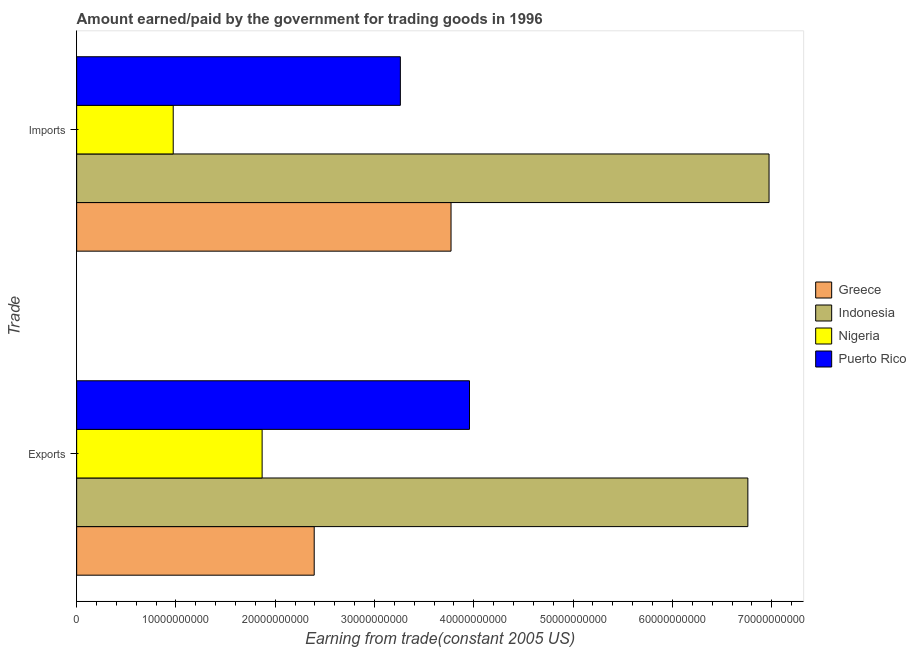Are the number of bars on each tick of the Y-axis equal?
Make the answer very short. Yes. How many bars are there on the 1st tick from the bottom?
Offer a terse response. 4. What is the label of the 1st group of bars from the top?
Your answer should be very brief. Imports. What is the amount paid for imports in Nigeria?
Your response must be concise. 9.72e+09. Across all countries, what is the maximum amount paid for imports?
Offer a very short reply. 6.97e+1. Across all countries, what is the minimum amount earned from exports?
Provide a succinct answer. 1.87e+1. In which country was the amount earned from exports minimum?
Give a very brief answer. Nigeria. What is the total amount paid for imports in the graph?
Offer a very short reply. 1.50e+11. What is the difference between the amount paid for imports in Nigeria and that in Greece?
Keep it short and to the point. -2.80e+1. What is the difference between the amount paid for imports in Puerto Rico and the amount earned from exports in Indonesia?
Give a very brief answer. -3.50e+1. What is the average amount earned from exports per country?
Your answer should be compact. 3.74e+1. What is the difference between the amount earned from exports and amount paid for imports in Nigeria?
Make the answer very short. 8.95e+09. In how many countries, is the amount paid for imports greater than 10000000000 US$?
Your response must be concise. 3. What is the ratio of the amount earned from exports in Greece to that in Nigeria?
Your answer should be very brief. 1.28. Is the amount paid for imports in Puerto Rico less than that in Indonesia?
Ensure brevity in your answer.  Yes. What does the 3rd bar from the top in Exports represents?
Make the answer very short. Indonesia. What does the 2nd bar from the bottom in Imports represents?
Keep it short and to the point. Indonesia. How many bars are there?
Give a very brief answer. 8. Are all the bars in the graph horizontal?
Your response must be concise. Yes. How many countries are there in the graph?
Provide a short and direct response. 4. What is the difference between two consecutive major ticks on the X-axis?
Give a very brief answer. 1.00e+1. Where does the legend appear in the graph?
Ensure brevity in your answer.  Center right. How are the legend labels stacked?
Your answer should be compact. Vertical. What is the title of the graph?
Provide a short and direct response. Amount earned/paid by the government for trading goods in 1996. Does "Virgin Islands" appear as one of the legend labels in the graph?
Make the answer very short. No. What is the label or title of the X-axis?
Provide a succinct answer. Earning from trade(constant 2005 US). What is the label or title of the Y-axis?
Provide a short and direct response. Trade. What is the Earning from trade(constant 2005 US) in Greece in Exports?
Your answer should be very brief. 2.39e+1. What is the Earning from trade(constant 2005 US) in Indonesia in Exports?
Provide a short and direct response. 6.76e+1. What is the Earning from trade(constant 2005 US) of Nigeria in Exports?
Keep it short and to the point. 1.87e+1. What is the Earning from trade(constant 2005 US) in Puerto Rico in Exports?
Offer a terse response. 3.96e+1. What is the Earning from trade(constant 2005 US) in Greece in Imports?
Your answer should be compact. 3.77e+1. What is the Earning from trade(constant 2005 US) of Indonesia in Imports?
Provide a short and direct response. 6.97e+1. What is the Earning from trade(constant 2005 US) in Nigeria in Imports?
Make the answer very short. 9.72e+09. What is the Earning from trade(constant 2005 US) in Puerto Rico in Imports?
Make the answer very short. 3.26e+1. Across all Trade, what is the maximum Earning from trade(constant 2005 US) in Greece?
Give a very brief answer. 3.77e+1. Across all Trade, what is the maximum Earning from trade(constant 2005 US) of Indonesia?
Make the answer very short. 6.97e+1. Across all Trade, what is the maximum Earning from trade(constant 2005 US) in Nigeria?
Provide a short and direct response. 1.87e+1. Across all Trade, what is the maximum Earning from trade(constant 2005 US) in Puerto Rico?
Provide a succinct answer. 3.96e+1. Across all Trade, what is the minimum Earning from trade(constant 2005 US) in Greece?
Offer a terse response. 2.39e+1. Across all Trade, what is the minimum Earning from trade(constant 2005 US) of Indonesia?
Offer a very short reply. 6.76e+1. Across all Trade, what is the minimum Earning from trade(constant 2005 US) in Nigeria?
Your response must be concise. 9.72e+09. Across all Trade, what is the minimum Earning from trade(constant 2005 US) of Puerto Rico?
Offer a terse response. 3.26e+1. What is the total Earning from trade(constant 2005 US) in Greece in the graph?
Ensure brevity in your answer.  6.16e+1. What is the total Earning from trade(constant 2005 US) in Indonesia in the graph?
Your answer should be compact. 1.37e+11. What is the total Earning from trade(constant 2005 US) of Nigeria in the graph?
Provide a short and direct response. 2.84e+1. What is the total Earning from trade(constant 2005 US) in Puerto Rico in the graph?
Provide a short and direct response. 7.22e+1. What is the difference between the Earning from trade(constant 2005 US) in Greece in Exports and that in Imports?
Provide a short and direct response. -1.38e+1. What is the difference between the Earning from trade(constant 2005 US) in Indonesia in Exports and that in Imports?
Provide a short and direct response. -2.13e+09. What is the difference between the Earning from trade(constant 2005 US) of Nigeria in Exports and that in Imports?
Give a very brief answer. 8.95e+09. What is the difference between the Earning from trade(constant 2005 US) of Puerto Rico in Exports and that in Imports?
Provide a short and direct response. 6.96e+09. What is the difference between the Earning from trade(constant 2005 US) of Greece in Exports and the Earning from trade(constant 2005 US) of Indonesia in Imports?
Your answer should be very brief. -4.58e+1. What is the difference between the Earning from trade(constant 2005 US) in Greece in Exports and the Earning from trade(constant 2005 US) in Nigeria in Imports?
Provide a short and direct response. 1.42e+1. What is the difference between the Earning from trade(constant 2005 US) in Greece in Exports and the Earning from trade(constant 2005 US) in Puerto Rico in Imports?
Your answer should be very brief. -8.68e+09. What is the difference between the Earning from trade(constant 2005 US) in Indonesia in Exports and the Earning from trade(constant 2005 US) in Nigeria in Imports?
Provide a short and direct response. 5.79e+1. What is the difference between the Earning from trade(constant 2005 US) of Indonesia in Exports and the Earning from trade(constant 2005 US) of Puerto Rico in Imports?
Ensure brevity in your answer.  3.50e+1. What is the difference between the Earning from trade(constant 2005 US) of Nigeria in Exports and the Earning from trade(constant 2005 US) of Puerto Rico in Imports?
Provide a short and direct response. -1.39e+1. What is the average Earning from trade(constant 2005 US) in Greece per Trade?
Make the answer very short. 3.08e+1. What is the average Earning from trade(constant 2005 US) in Indonesia per Trade?
Give a very brief answer. 6.87e+1. What is the average Earning from trade(constant 2005 US) of Nigeria per Trade?
Your answer should be very brief. 1.42e+1. What is the average Earning from trade(constant 2005 US) of Puerto Rico per Trade?
Give a very brief answer. 3.61e+1. What is the difference between the Earning from trade(constant 2005 US) in Greece and Earning from trade(constant 2005 US) in Indonesia in Exports?
Provide a short and direct response. -4.37e+1. What is the difference between the Earning from trade(constant 2005 US) of Greece and Earning from trade(constant 2005 US) of Nigeria in Exports?
Provide a short and direct response. 5.24e+09. What is the difference between the Earning from trade(constant 2005 US) in Greece and Earning from trade(constant 2005 US) in Puerto Rico in Exports?
Provide a short and direct response. -1.56e+1. What is the difference between the Earning from trade(constant 2005 US) in Indonesia and Earning from trade(constant 2005 US) in Nigeria in Exports?
Offer a terse response. 4.89e+1. What is the difference between the Earning from trade(constant 2005 US) of Indonesia and Earning from trade(constant 2005 US) of Puerto Rico in Exports?
Your answer should be compact. 2.80e+1. What is the difference between the Earning from trade(constant 2005 US) in Nigeria and Earning from trade(constant 2005 US) in Puerto Rico in Exports?
Provide a succinct answer. -2.09e+1. What is the difference between the Earning from trade(constant 2005 US) of Greece and Earning from trade(constant 2005 US) of Indonesia in Imports?
Offer a terse response. -3.20e+1. What is the difference between the Earning from trade(constant 2005 US) in Greece and Earning from trade(constant 2005 US) in Nigeria in Imports?
Ensure brevity in your answer.  2.80e+1. What is the difference between the Earning from trade(constant 2005 US) in Greece and Earning from trade(constant 2005 US) in Puerto Rico in Imports?
Offer a very short reply. 5.10e+09. What is the difference between the Earning from trade(constant 2005 US) in Indonesia and Earning from trade(constant 2005 US) in Nigeria in Imports?
Make the answer very short. 6.00e+1. What is the difference between the Earning from trade(constant 2005 US) in Indonesia and Earning from trade(constant 2005 US) in Puerto Rico in Imports?
Your response must be concise. 3.71e+1. What is the difference between the Earning from trade(constant 2005 US) in Nigeria and Earning from trade(constant 2005 US) in Puerto Rico in Imports?
Offer a very short reply. -2.29e+1. What is the ratio of the Earning from trade(constant 2005 US) in Greece in Exports to that in Imports?
Offer a very short reply. 0.63. What is the ratio of the Earning from trade(constant 2005 US) of Indonesia in Exports to that in Imports?
Offer a terse response. 0.97. What is the ratio of the Earning from trade(constant 2005 US) in Nigeria in Exports to that in Imports?
Offer a terse response. 1.92. What is the ratio of the Earning from trade(constant 2005 US) of Puerto Rico in Exports to that in Imports?
Provide a short and direct response. 1.21. What is the difference between the highest and the second highest Earning from trade(constant 2005 US) of Greece?
Your answer should be compact. 1.38e+1. What is the difference between the highest and the second highest Earning from trade(constant 2005 US) of Indonesia?
Offer a very short reply. 2.13e+09. What is the difference between the highest and the second highest Earning from trade(constant 2005 US) of Nigeria?
Your answer should be compact. 8.95e+09. What is the difference between the highest and the second highest Earning from trade(constant 2005 US) in Puerto Rico?
Provide a short and direct response. 6.96e+09. What is the difference between the highest and the lowest Earning from trade(constant 2005 US) in Greece?
Offer a very short reply. 1.38e+1. What is the difference between the highest and the lowest Earning from trade(constant 2005 US) of Indonesia?
Provide a succinct answer. 2.13e+09. What is the difference between the highest and the lowest Earning from trade(constant 2005 US) of Nigeria?
Give a very brief answer. 8.95e+09. What is the difference between the highest and the lowest Earning from trade(constant 2005 US) of Puerto Rico?
Provide a succinct answer. 6.96e+09. 